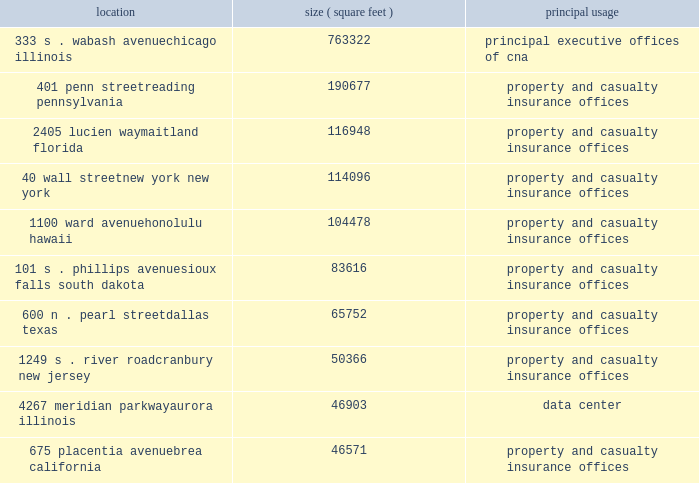Item 1 .
Business cna financial corporation 2013 ( continued ) unpredictability in the law , insurance underwriting is expected to continue to be difficult in commercial lines , professional liability and other specialty coverages .
The dodd-frank wall street reform and consumer protection act expands the federal presence in insurance oversight and may increase the regulatory requirements to which cna may be subject .
The act 2019s requirements include streamlining the state-based regulation of reinsurance and nonadmitted insurance ( property or casualty insurance placed from insurers that are eligible to accept insurance , but are not licensed to write insurance in a particular state ) .
The act also establishes a new federal insurance office within the u.s .
Department of the treasury with powers over all lines of insurance except health insurance , certain long term care insurance and crop insurance , to , among other things , monitor aspects of the insurance industry , identify issues in the regulation of insurers that could contribute to a systemic crisis in the insurance industry or the overall financial system , coordinate federal policy on international insurance matters and preempt state insurance measures under certain circumstances .
The act calls for numerous studies and contemplates further regulation .
The patient protection and affordable care act and the related amendments in the health care and education reconciliation act may increase cna 2019s operating costs and underwriting losses .
This landmark legislation may lead to numerous changes in the health care industry that could create additional operating costs for cna , particularly with respect to workers 2019 compensation and long term care products .
These costs might arise through the increased use of health care services by claimants or the increased complexities in health care bills that could require additional levels of review .
In addition , due to the expected number of new participants in the health care system and the potential for additional malpractice claims , cna may experience increased underwriting risk in the lines of business that provide management and professional liability insurance to individuals and businesses engaged in the health care industry .
The lines of business that provide professional liability insurance to attorneys , accountants and other professionals who advise clients regarding the health care reform legislation may also experience increased underwriting risk due to the complexity of the legislation .
Properties : the chicago location owned by ccc , a wholly owned subsidiary of cna , houses cna 2019s principal executive offices .
Cna owns or leases office space in various cities throughout the united states and in other countries .
The table sets forth certain information with respect to cna 2019s principal office locations : location ( square feet ) principal usage 333 s .
Wabash avenue 763322 principal executive offices of cna chicago , illinois 401 penn street 190677 property and casualty insurance offices reading , pennsylvania 2405 lucien way 116948 property and casualty insurance offices maitland , florida 40 wall street 114096 property and casualty insurance offices new york , new york 1100 ward avenue 104478 property and casualty insurance offices honolulu , hawaii 101 s .
Phillips avenue 83616 property and casualty insurance offices sioux falls , south dakota 600 n .
Pearl street 65752 property and casualty insurance offices dallas , texas 1249 s .
River road 50366 property and casualty insurance offices cranbury , new jersey 4267 meridian parkway 46903 data center aurora , illinois 675 placentia avenue 46571 property and casualty insurance offices brea , california cna leases its office space described above except for the chicago , illinois building , the reading , pennsylvania building , and the aurora , illinois building , which are owned. .
Item 1 .
Business cna financial corporation 2013 ( continued ) unpredictability in the law , insurance underwriting is expected to continue to be difficult in commercial lines , professional liability and other specialty coverages .
The dodd-frank wall street reform and consumer protection act expands the federal presence in insurance oversight and may increase the regulatory requirements to which cna may be subject .
The act 2019s requirements include streamlining the state-based regulation of reinsurance and nonadmitted insurance ( property or casualty insurance placed from insurers that are eligible to accept insurance , but are not licensed to write insurance in a particular state ) .
The act also establishes a new federal insurance office within the u.s .
Department of the treasury with powers over all lines of insurance except health insurance , certain long term care insurance and crop insurance , to , among other things , monitor aspects of the insurance industry , identify issues in the regulation of insurers that could contribute to a systemic crisis in the insurance industry or the overall financial system , coordinate federal policy on international insurance matters and preempt state insurance measures under certain circumstances .
The act calls for numerous studies and contemplates further regulation .
The patient protection and affordable care act and the related amendments in the health care and education reconciliation act may increase cna 2019s operating costs and underwriting losses .
This landmark legislation may lead to numerous changes in the health care industry that could create additional operating costs for cna , particularly with respect to workers 2019 compensation and long term care products .
These costs might arise through the increased use of health care services by claimants or the increased complexities in health care bills that could require additional levels of review .
In addition , due to the expected number of new participants in the health care system and the potential for additional malpractice claims , cna may experience increased underwriting risk in the lines of business that provide management and professional liability insurance to individuals and businesses engaged in the health care industry .
The lines of business that provide professional liability insurance to attorneys , accountants and other professionals who advise clients regarding the health care reform legislation may also experience increased underwriting risk due to the complexity of the legislation .
Properties : the chicago location owned by ccc , a wholly owned subsidiary of cna , houses cna 2019s principal executive offices .
Cna owns or leases office space in various cities throughout the united states and in other countries .
The following table sets forth certain information with respect to cna 2019s principal office locations : location ( square feet ) principal usage 333 s .
Wabash avenue 763322 principal executive offices of cna chicago , illinois 401 penn street 190677 property and casualty insurance offices reading , pennsylvania 2405 lucien way 116948 property and casualty insurance offices maitland , florida 40 wall street 114096 property and casualty insurance offices new york , new york 1100 ward avenue 104478 property and casualty insurance offices honolulu , hawaii 101 s .
Phillips avenue 83616 property and casualty insurance offices sioux falls , south dakota 600 n .
Pearl street 65752 property and casualty insurance offices dallas , texas 1249 s .
River road 50366 property and casualty insurance offices cranbury , new jersey 4267 meridian parkway 46903 data center aurora , illinois 675 placentia avenue 46571 property and casualty insurance offices brea , california cna leases its office space described above except for the chicago , illinois building , the reading , pennsylvania building , and the aurora , illinois building , which are owned. .
Does cna have a large physical presence in south dakota than in texas? 
Computations: (83616 > 65752)
Answer: yes. 